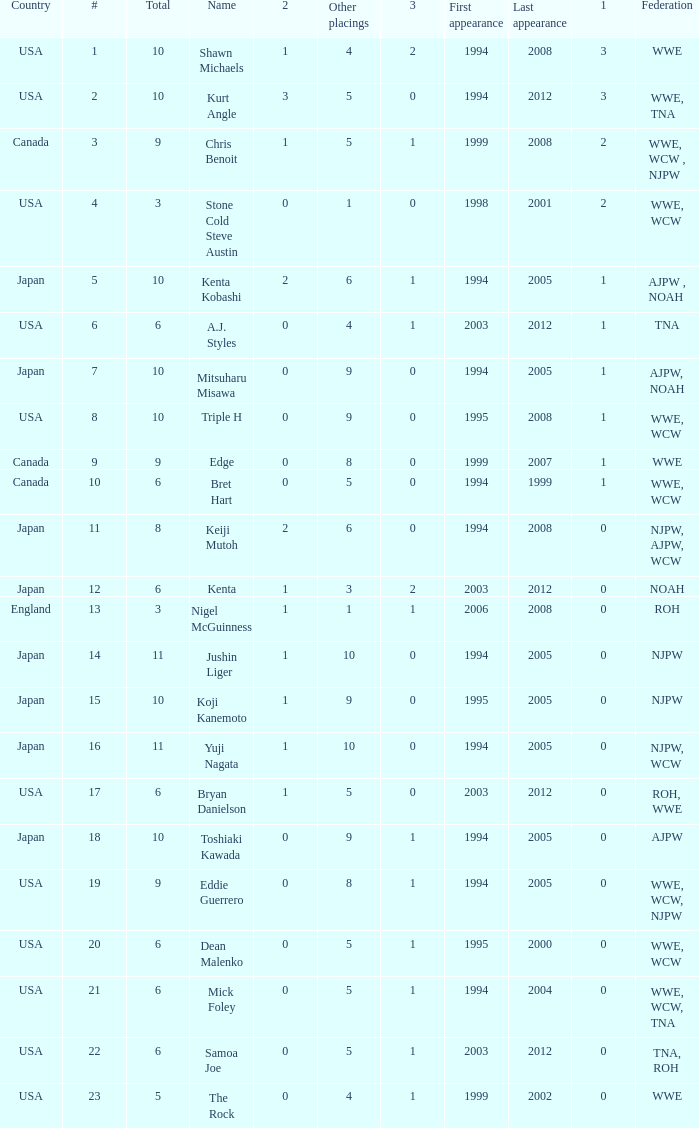How many times has a wrestler from the country of England wrestled in this event? 1.0. 